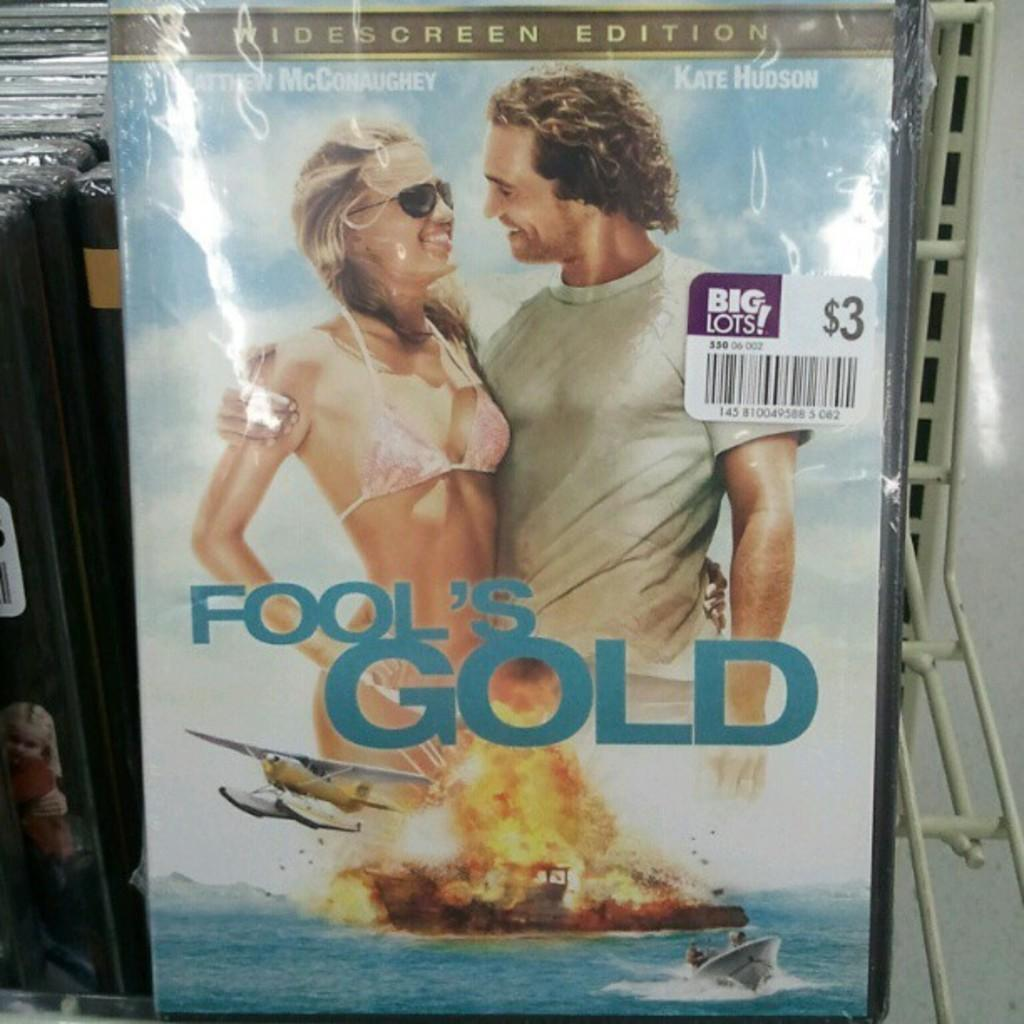<image>
Render a clear and concise summary of the photo. The cover of the movie Fool's Gold starring Kate Hudson and Matthew McConaughey 